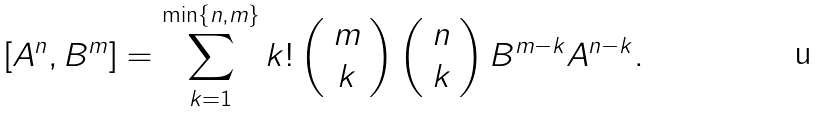<formula> <loc_0><loc_0><loc_500><loc_500>[ A ^ { n } , B ^ { m } ] = \sum _ { k = 1 } ^ { \min \{ n , m \} } k ! \left ( \begin{array} { c } m \\ k \end{array} \right ) \left ( \begin{array} { c } n \\ k \end{array} \right ) B ^ { m - k } A ^ { n - k } .</formula> 